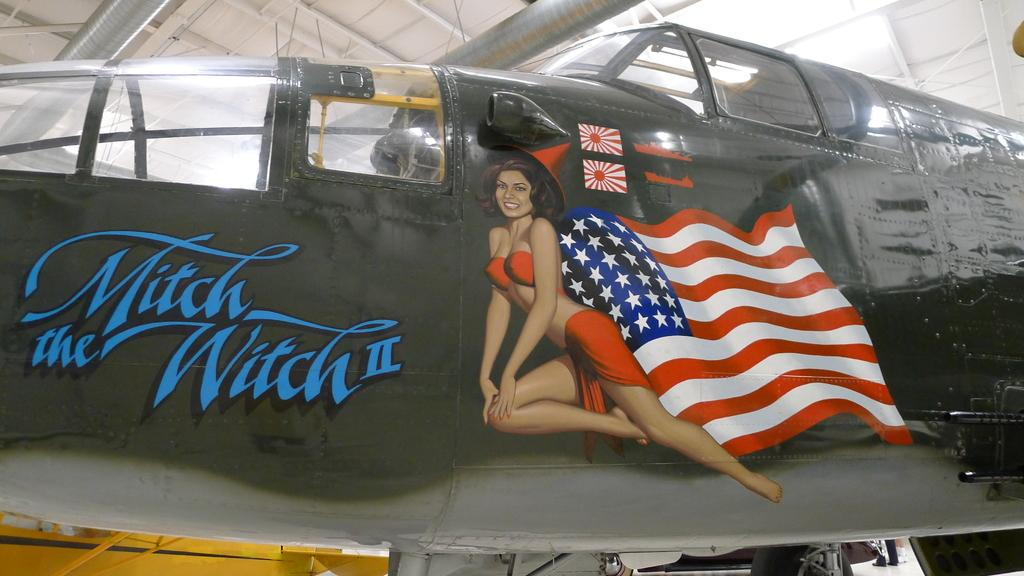<image>
Present a compact description of the photo's key features. The Mitch Witch II with a american flag picture on a black airplane. 